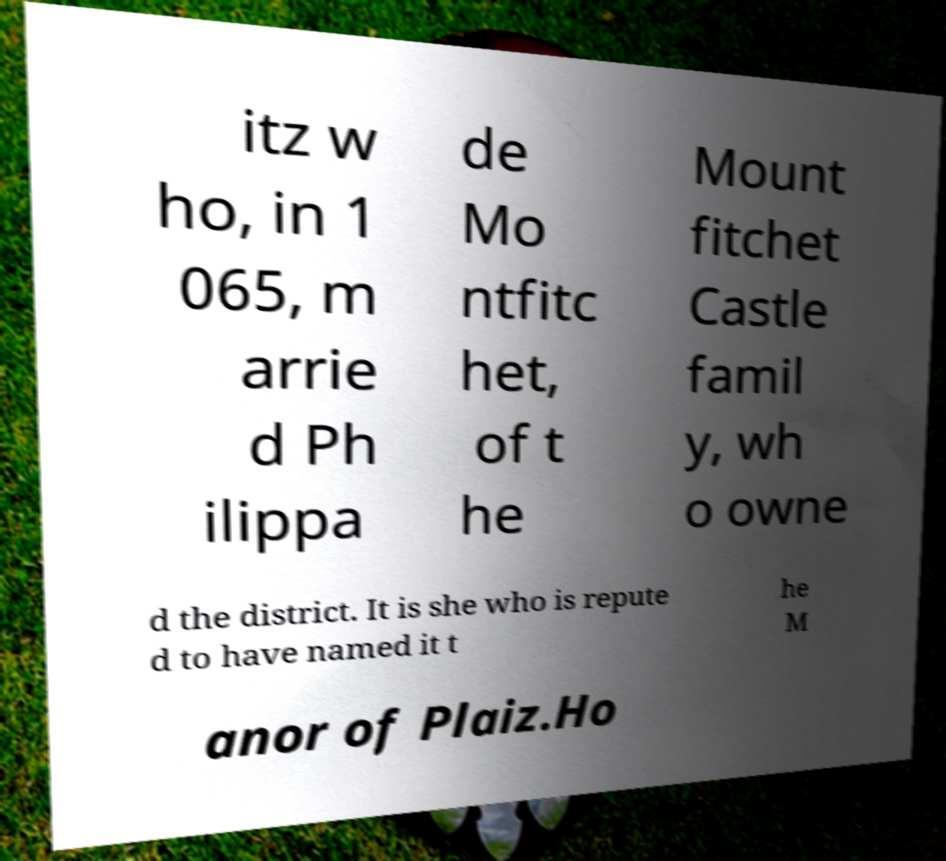There's text embedded in this image that I need extracted. Can you transcribe it verbatim? itz w ho, in 1 065, m arrie d Ph ilippa de Mo ntfitc het, of t he Mount fitchet Castle famil y, wh o owne d the district. It is she who is repute d to have named it t he M anor of Plaiz.Ho 